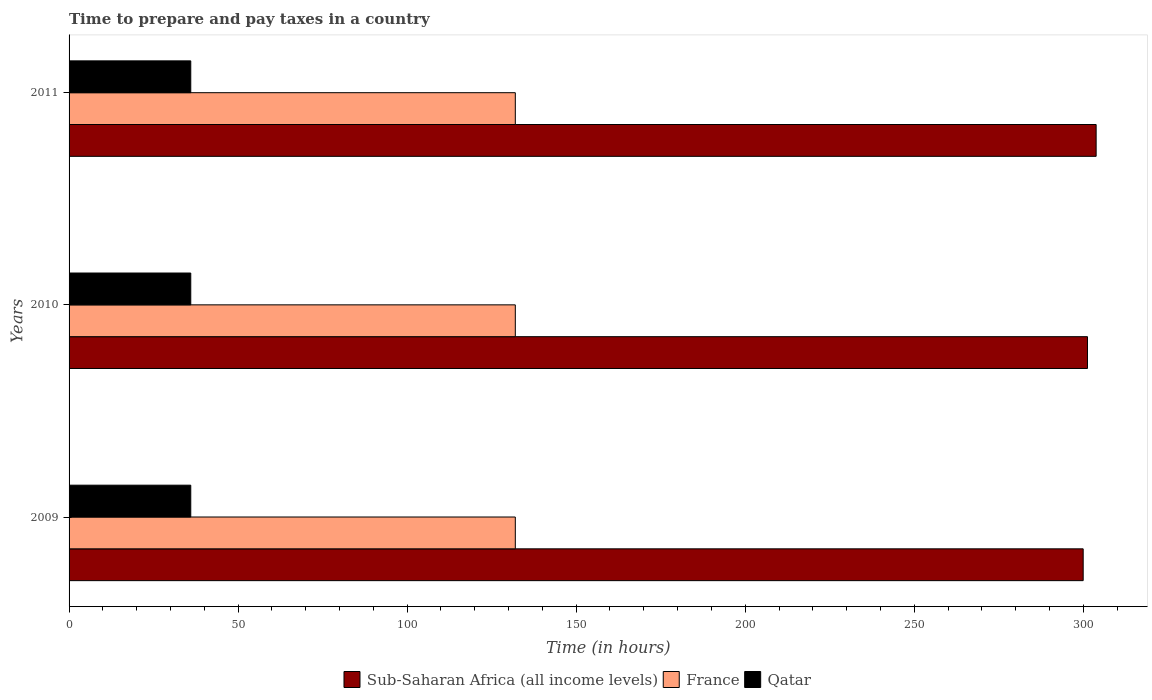How many groups of bars are there?
Your answer should be compact. 3. Are the number of bars per tick equal to the number of legend labels?
Your answer should be compact. Yes. How many bars are there on the 3rd tick from the top?
Offer a very short reply. 3. In how many cases, is the number of bars for a given year not equal to the number of legend labels?
Offer a very short reply. 0. What is the number of hours required to prepare and pay taxes in France in 2009?
Give a very brief answer. 132. Across all years, what is the minimum number of hours required to prepare and pay taxes in France?
Offer a very short reply. 132. In which year was the number of hours required to prepare and pay taxes in Sub-Saharan Africa (all income levels) maximum?
Your response must be concise. 2011. What is the total number of hours required to prepare and pay taxes in Sub-Saharan Africa (all income levels) in the graph?
Provide a short and direct response. 905.04. What is the difference between the number of hours required to prepare and pay taxes in Sub-Saharan Africa (all income levels) in 2010 and that in 2011?
Provide a succinct answer. -2.56. What is the difference between the number of hours required to prepare and pay taxes in Sub-Saharan Africa (all income levels) in 2010 and the number of hours required to prepare and pay taxes in France in 2009?
Your answer should be very brief. 169.25. What is the average number of hours required to prepare and pay taxes in Qatar per year?
Offer a very short reply. 36. In the year 2010, what is the difference between the number of hours required to prepare and pay taxes in Qatar and number of hours required to prepare and pay taxes in France?
Provide a short and direct response. -96. Is the number of hours required to prepare and pay taxes in Qatar in 2009 less than that in 2011?
Ensure brevity in your answer.  No. What is the difference between the highest and the second highest number of hours required to prepare and pay taxes in Qatar?
Keep it short and to the point. 0. What is the difference between the highest and the lowest number of hours required to prepare and pay taxes in Sub-Saharan Africa (all income levels)?
Offer a very short reply. 3.83. In how many years, is the number of hours required to prepare and pay taxes in Qatar greater than the average number of hours required to prepare and pay taxes in Qatar taken over all years?
Your answer should be compact. 0. Is the sum of the number of hours required to prepare and pay taxes in Sub-Saharan Africa (all income levels) in 2010 and 2011 greater than the maximum number of hours required to prepare and pay taxes in France across all years?
Ensure brevity in your answer.  Yes. What does the 3rd bar from the top in 2009 represents?
Your answer should be compact. Sub-Saharan Africa (all income levels). Is it the case that in every year, the sum of the number of hours required to prepare and pay taxes in France and number of hours required to prepare and pay taxes in Qatar is greater than the number of hours required to prepare and pay taxes in Sub-Saharan Africa (all income levels)?
Offer a very short reply. No. How many bars are there?
Provide a short and direct response. 9. How many years are there in the graph?
Your response must be concise. 3. How are the legend labels stacked?
Your answer should be very brief. Horizontal. What is the title of the graph?
Your answer should be very brief. Time to prepare and pay taxes in a country. What is the label or title of the X-axis?
Your answer should be compact. Time (in hours). What is the Time (in hours) of Sub-Saharan Africa (all income levels) in 2009?
Ensure brevity in your answer.  299.98. What is the Time (in hours) in France in 2009?
Your answer should be very brief. 132. What is the Time (in hours) of Sub-Saharan Africa (all income levels) in 2010?
Give a very brief answer. 301.25. What is the Time (in hours) of France in 2010?
Keep it short and to the point. 132. What is the Time (in hours) of Qatar in 2010?
Give a very brief answer. 36. What is the Time (in hours) in Sub-Saharan Africa (all income levels) in 2011?
Offer a terse response. 303.81. What is the Time (in hours) in France in 2011?
Keep it short and to the point. 132. What is the Time (in hours) of Qatar in 2011?
Provide a succinct answer. 36. Across all years, what is the maximum Time (in hours) of Sub-Saharan Africa (all income levels)?
Your answer should be very brief. 303.81. Across all years, what is the maximum Time (in hours) of France?
Provide a succinct answer. 132. Across all years, what is the maximum Time (in hours) of Qatar?
Give a very brief answer. 36. Across all years, what is the minimum Time (in hours) in Sub-Saharan Africa (all income levels)?
Your answer should be compact. 299.98. Across all years, what is the minimum Time (in hours) of France?
Offer a very short reply. 132. Across all years, what is the minimum Time (in hours) in Qatar?
Your answer should be very brief. 36. What is the total Time (in hours) in Sub-Saharan Africa (all income levels) in the graph?
Keep it short and to the point. 905.04. What is the total Time (in hours) of France in the graph?
Your response must be concise. 396. What is the total Time (in hours) of Qatar in the graph?
Ensure brevity in your answer.  108. What is the difference between the Time (in hours) of Sub-Saharan Africa (all income levels) in 2009 and that in 2010?
Make the answer very short. -1.27. What is the difference between the Time (in hours) in Qatar in 2009 and that in 2010?
Provide a succinct answer. 0. What is the difference between the Time (in hours) of Sub-Saharan Africa (all income levels) in 2009 and that in 2011?
Ensure brevity in your answer.  -3.83. What is the difference between the Time (in hours) of Sub-Saharan Africa (all income levels) in 2010 and that in 2011?
Your answer should be very brief. -2.56. What is the difference between the Time (in hours) in Sub-Saharan Africa (all income levels) in 2009 and the Time (in hours) in France in 2010?
Give a very brief answer. 167.98. What is the difference between the Time (in hours) of Sub-Saharan Africa (all income levels) in 2009 and the Time (in hours) of Qatar in 2010?
Make the answer very short. 263.98. What is the difference between the Time (in hours) of France in 2009 and the Time (in hours) of Qatar in 2010?
Your response must be concise. 96. What is the difference between the Time (in hours) in Sub-Saharan Africa (all income levels) in 2009 and the Time (in hours) in France in 2011?
Provide a short and direct response. 167.98. What is the difference between the Time (in hours) of Sub-Saharan Africa (all income levels) in 2009 and the Time (in hours) of Qatar in 2011?
Provide a short and direct response. 263.98. What is the difference between the Time (in hours) of France in 2009 and the Time (in hours) of Qatar in 2011?
Keep it short and to the point. 96. What is the difference between the Time (in hours) of Sub-Saharan Africa (all income levels) in 2010 and the Time (in hours) of France in 2011?
Your answer should be very brief. 169.25. What is the difference between the Time (in hours) of Sub-Saharan Africa (all income levels) in 2010 and the Time (in hours) of Qatar in 2011?
Keep it short and to the point. 265.25. What is the difference between the Time (in hours) of France in 2010 and the Time (in hours) of Qatar in 2011?
Ensure brevity in your answer.  96. What is the average Time (in hours) in Sub-Saharan Africa (all income levels) per year?
Give a very brief answer. 301.68. What is the average Time (in hours) of France per year?
Provide a succinct answer. 132. What is the average Time (in hours) of Qatar per year?
Keep it short and to the point. 36. In the year 2009, what is the difference between the Time (in hours) of Sub-Saharan Africa (all income levels) and Time (in hours) of France?
Ensure brevity in your answer.  167.98. In the year 2009, what is the difference between the Time (in hours) of Sub-Saharan Africa (all income levels) and Time (in hours) of Qatar?
Provide a short and direct response. 263.98. In the year 2009, what is the difference between the Time (in hours) of France and Time (in hours) of Qatar?
Your response must be concise. 96. In the year 2010, what is the difference between the Time (in hours) of Sub-Saharan Africa (all income levels) and Time (in hours) of France?
Your answer should be compact. 169.25. In the year 2010, what is the difference between the Time (in hours) in Sub-Saharan Africa (all income levels) and Time (in hours) in Qatar?
Make the answer very short. 265.25. In the year 2010, what is the difference between the Time (in hours) of France and Time (in hours) of Qatar?
Offer a terse response. 96. In the year 2011, what is the difference between the Time (in hours) in Sub-Saharan Africa (all income levels) and Time (in hours) in France?
Your answer should be very brief. 171.81. In the year 2011, what is the difference between the Time (in hours) in Sub-Saharan Africa (all income levels) and Time (in hours) in Qatar?
Your answer should be compact. 267.81. In the year 2011, what is the difference between the Time (in hours) in France and Time (in hours) in Qatar?
Offer a terse response. 96. What is the ratio of the Time (in hours) in Sub-Saharan Africa (all income levels) in 2009 to that in 2010?
Your answer should be very brief. 1. What is the ratio of the Time (in hours) of France in 2009 to that in 2010?
Make the answer very short. 1. What is the ratio of the Time (in hours) in Qatar in 2009 to that in 2010?
Give a very brief answer. 1. What is the ratio of the Time (in hours) in Sub-Saharan Africa (all income levels) in 2009 to that in 2011?
Your answer should be compact. 0.99. What is the difference between the highest and the second highest Time (in hours) of Sub-Saharan Africa (all income levels)?
Offer a very short reply. 2.56. What is the difference between the highest and the second highest Time (in hours) in France?
Keep it short and to the point. 0. What is the difference between the highest and the lowest Time (in hours) in Sub-Saharan Africa (all income levels)?
Provide a short and direct response. 3.83. What is the difference between the highest and the lowest Time (in hours) in France?
Make the answer very short. 0. What is the difference between the highest and the lowest Time (in hours) of Qatar?
Provide a succinct answer. 0. 